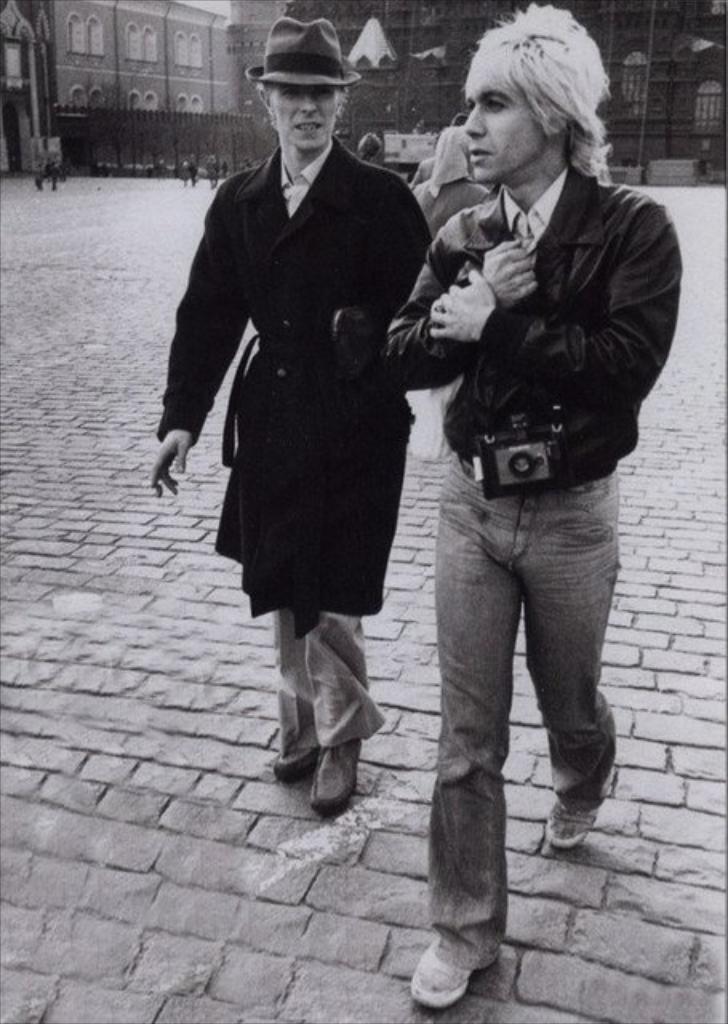Can you describe this image briefly? In this image we can see few buildings. There are few people in the image. A person is carrying an object in the image. 